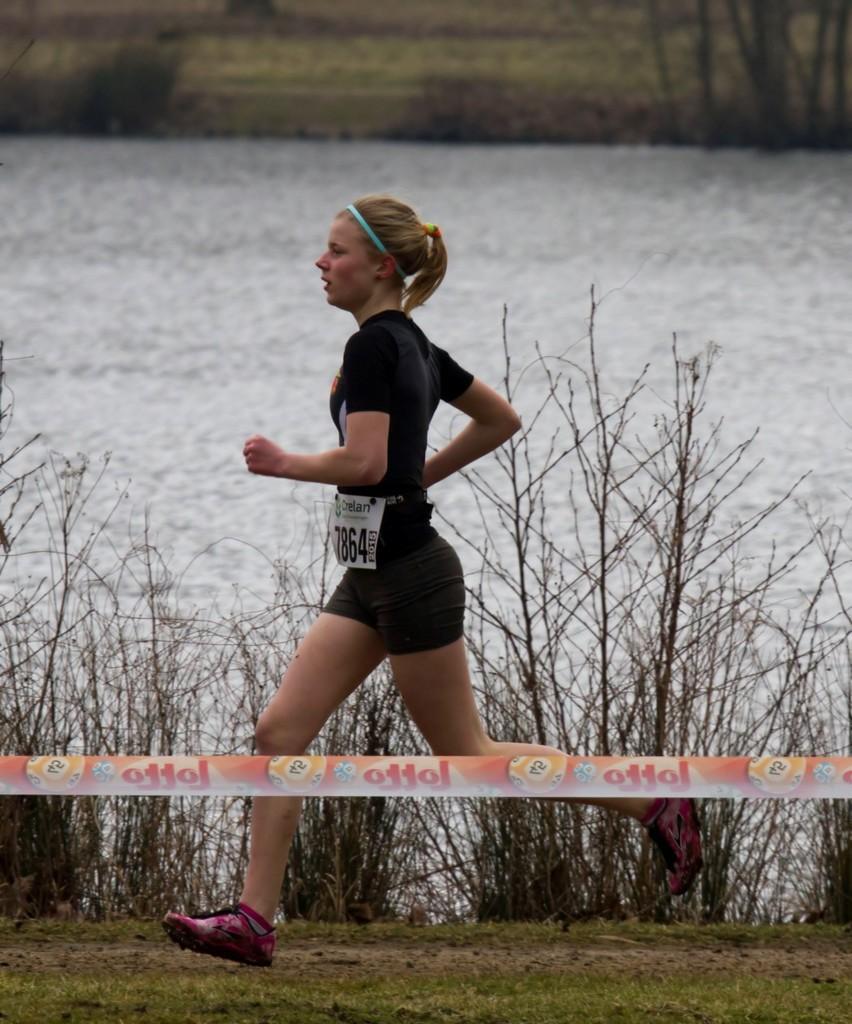Describe this image in one or two sentences. In this image I can see a person running and wearing black color dress. I can see few dry trees and water. 